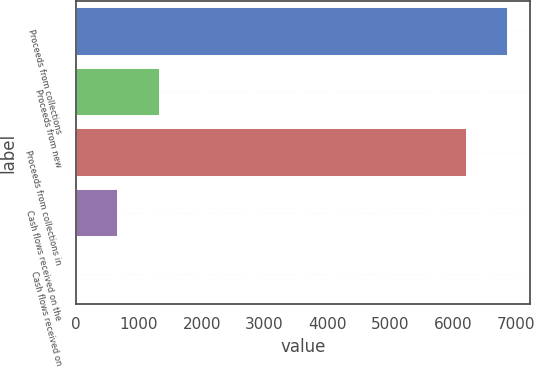Convert chart to OTSL. <chart><loc_0><loc_0><loc_500><loc_500><bar_chart><fcel>Proceeds from collections<fcel>Proceeds from new<fcel>Proceeds from collections in<fcel>Cash flows received on the<fcel>Cash flows received on<nl><fcel>6872.13<fcel>1331.46<fcel>6211.1<fcel>670.43<fcel>9.4<nl></chart> 